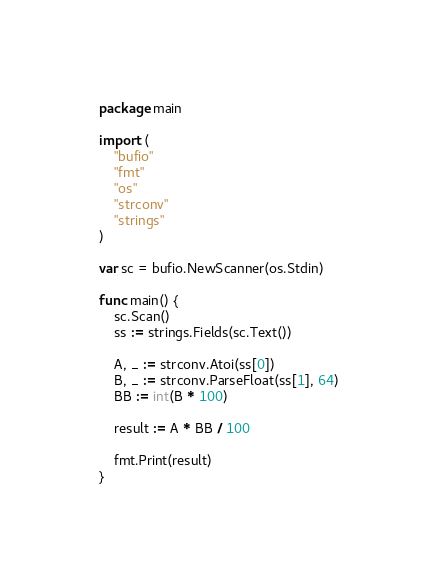<code> <loc_0><loc_0><loc_500><loc_500><_Go_>package main

import (
	"bufio"
	"fmt"
	"os"
	"strconv"
	"strings"
)

var sc = bufio.NewScanner(os.Stdin)

func main() {
	sc.Scan()
	ss := strings.Fields(sc.Text())

	A, _ := strconv.Atoi(ss[0])
	B, _ := strconv.ParseFloat(ss[1], 64)
	BB := int(B * 100)

	result := A * BB / 100

	fmt.Print(result)
}
</code> 